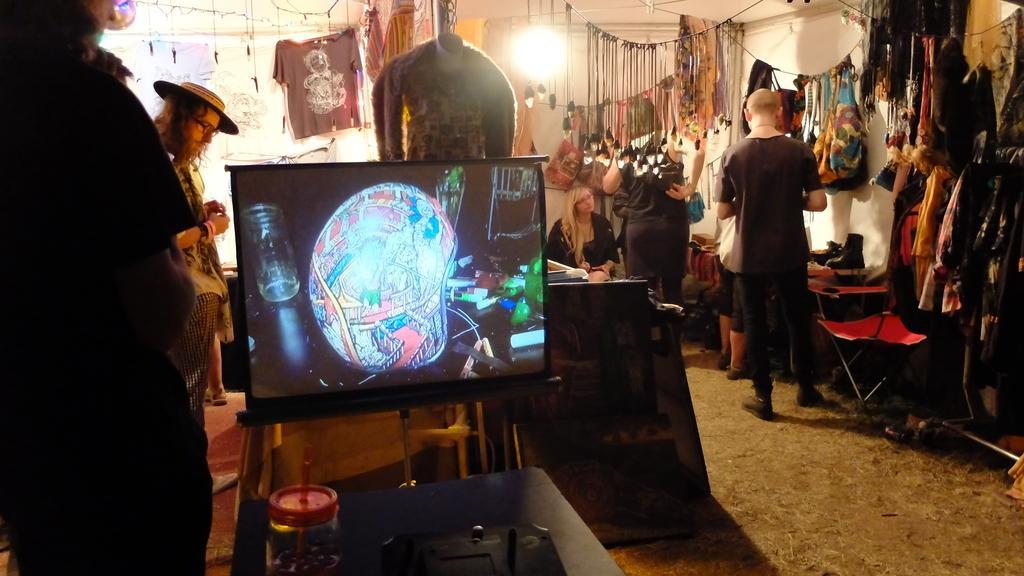Describe this image in one or two sentences. In the foreground of this image, there is a table and a jar on it. On the left, there are persons and a screen. In the background, there are tables, few persons, clothes and bulbs are hanging and there is a wall. 